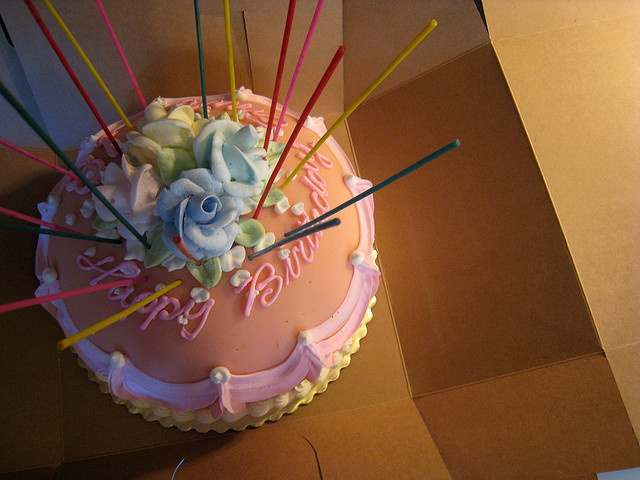Describe the objects in this image and their specific colors. I can see a cake in black, maroon, gray, and brown tones in this image. 